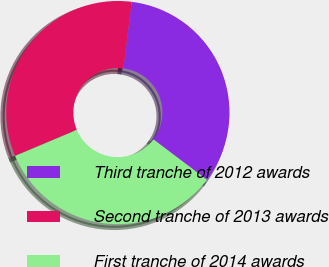<chart> <loc_0><loc_0><loc_500><loc_500><pie_chart><fcel>Third tranche of 2012 awards<fcel>Second tranche of 2013 awards<fcel>First tranche of 2014 awards<nl><fcel>33.3%<fcel>33.33%<fcel>33.37%<nl></chart> 